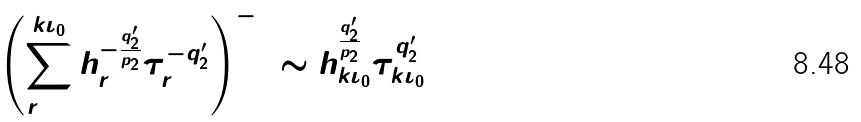<formula> <loc_0><loc_0><loc_500><loc_500>\left ( \sum _ { r = 1 } ^ { k \iota _ { 0 } } h _ { r } ^ { - \frac { q _ { 2 } ^ { \prime } } { p _ { 2 } } } \tau _ { r } ^ { - q _ { 2 } ^ { \prime } } \right ) ^ { - 1 } \sim h _ { k \iota _ { 0 } } ^ { \frac { q _ { 2 } ^ { \prime } } { p _ { 2 } } } \tau _ { k \iota _ { 0 } } ^ { q _ { 2 } ^ { \prime } }</formula> 